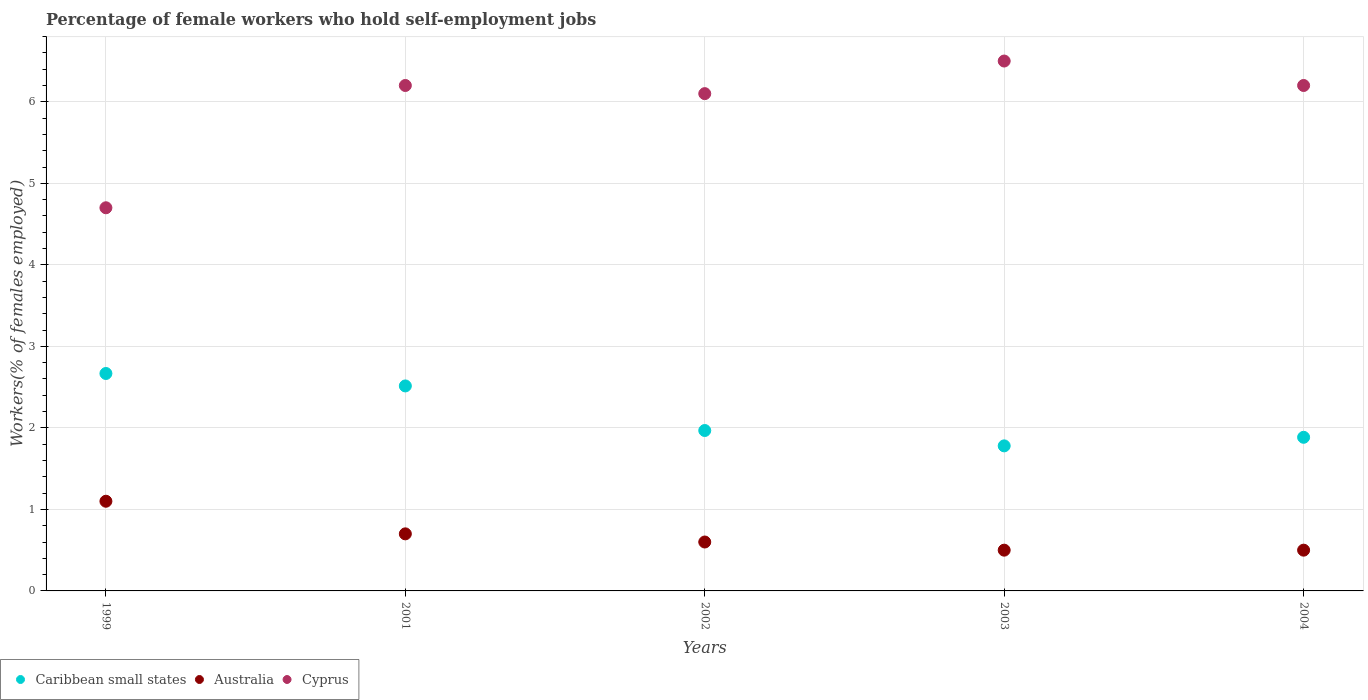Is the number of dotlines equal to the number of legend labels?
Offer a very short reply. Yes. What is the percentage of self-employed female workers in Cyprus in 1999?
Keep it short and to the point. 4.7. Across all years, what is the maximum percentage of self-employed female workers in Australia?
Make the answer very short. 1.1. Across all years, what is the minimum percentage of self-employed female workers in Cyprus?
Offer a very short reply. 4.7. In which year was the percentage of self-employed female workers in Australia maximum?
Offer a terse response. 1999. In which year was the percentage of self-employed female workers in Cyprus minimum?
Keep it short and to the point. 1999. What is the total percentage of self-employed female workers in Australia in the graph?
Provide a short and direct response. 3.4. What is the difference between the percentage of self-employed female workers in Cyprus in 1999 and that in 2002?
Ensure brevity in your answer.  -1.4. What is the difference between the percentage of self-employed female workers in Cyprus in 2004 and the percentage of self-employed female workers in Caribbean small states in 1999?
Ensure brevity in your answer.  3.53. What is the average percentage of self-employed female workers in Australia per year?
Your answer should be compact. 0.68. In the year 2001, what is the difference between the percentage of self-employed female workers in Cyprus and percentage of self-employed female workers in Australia?
Offer a terse response. 5.5. In how many years, is the percentage of self-employed female workers in Cyprus greater than 5.8 %?
Provide a succinct answer. 4. What is the ratio of the percentage of self-employed female workers in Australia in 1999 to that in 2004?
Offer a terse response. 2.2. Is the percentage of self-employed female workers in Caribbean small states in 2001 less than that in 2002?
Your response must be concise. No. What is the difference between the highest and the second highest percentage of self-employed female workers in Caribbean small states?
Provide a succinct answer. 0.15. What is the difference between the highest and the lowest percentage of self-employed female workers in Australia?
Offer a terse response. 0.6. Is the sum of the percentage of self-employed female workers in Caribbean small states in 2001 and 2004 greater than the maximum percentage of self-employed female workers in Cyprus across all years?
Keep it short and to the point. No. Is it the case that in every year, the sum of the percentage of self-employed female workers in Australia and percentage of self-employed female workers in Caribbean small states  is greater than the percentage of self-employed female workers in Cyprus?
Your response must be concise. No. Does the percentage of self-employed female workers in Cyprus monotonically increase over the years?
Provide a short and direct response. No. Is the percentage of self-employed female workers in Cyprus strictly less than the percentage of self-employed female workers in Caribbean small states over the years?
Provide a succinct answer. No. How many dotlines are there?
Give a very brief answer. 3. How many years are there in the graph?
Keep it short and to the point. 5. Are the values on the major ticks of Y-axis written in scientific E-notation?
Offer a very short reply. No. Does the graph contain grids?
Keep it short and to the point. Yes. How many legend labels are there?
Make the answer very short. 3. What is the title of the graph?
Your answer should be compact. Percentage of female workers who hold self-employment jobs. What is the label or title of the Y-axis?
Offer a terse response. Workers(% of females employed). What is the Workers(% of females employed) in Caribbean small states in 1999?
Your answer should be compact. 2.67. What is the Workers(% of females employed) in Australia in 1999?
Offer a terse response. 1.1. What is the Workers(% of females employed) in Cyprus in 1999?
Offer a terse response. 4.7. What is the Workers(% of females employed) of Caribbean small states in 2001?
Your answer should be very brief. 2.51. What is the Workers(% of females employed) of Australia in 2001?
Provide a succinct answer. 0.7. What is the Workers(% of females employed) in Cyprus in 2001?
Keep it short and to the point. 6.2. What is the Workers(% of females employed) in Caribbean small states in 2002?
Provide a succinct answer. 1.97. What is the Workers(% of females employed) of Australia in 2002?
Keep it short and to the point. 0.6. What is the Workers(% of females employed) in Cyprus in 2002?
Provide a short and direct response. 6.1. What is the Workers(% of females employed) of Caribbean small states in 2003?
Provide a succinct answer. 1.78. What is the Workers(% of females employed) of Australia in 2003?
Provide a succinct answer. 0.5. What is the Workers(% of females employed) of Cyprus in 2003?
Offer a terse response. 6.5. What is the Workers(% of females employed) of Caribbean small states in 2004?
Give a very brief answer. 1.88. What is the Workers(% of females employed) of Cyprus in 2004?
Offer a very short reply. 6.2. Across all years, what is the maximum Workers(% of females employed) of Caribbean small states?
Your answer should be very brief. 2.67. Across all years, what is the maximum Workers(% of females employed) in Australia?
Provide a succinct answer. 1.1. Across all years, what is the minimum Workers(% of females employed) of Caribbean small states?
Ensure brevity in your answer.  1.78. Across all years, what is the minimum Workers(% of females employed) in Cyprus?
Your answer should be very brief. 4.7. What is the total Workers(% of females employed) of Caribbean small states in the graph?
Offer a terse response. 10.81. What is the total Workers(% of females employed) in Cyprus in the graph?
Give a very brief answer. 29.7. What is the difference between the Workers(% of females employed) of Caribbean small states in 1999 and that in 2001?
Offer a terse response. 0.15. What is the difference between the Workers(% of females employed) in Cyprus in 1999 and that in 2001?
Offer a very short reply. -1.5. What is the difference between the Workers(% of females employed) in Caribbean small states in 1999 and that in 2002?
Your answer should be very brief. 0.7. What is the difference between the Workers(% of females employed) in Australia in 1999 and that in 2002?
Make the answer very short. 0.5. What is the difference between the Workers(% of females employed) of Caribbean small states in 1999 and that in 2003?
Your answer should be very brief. 0.89. What is the difference between the Workers(% of females employed) of Australia in 1999 and that in 2003?
Your answer should be very brief. 0.6. What is the difference between the Workers(% of females employed) in Caribbean small states in 1999 and that in 2004?
Ensure brevity in your answer.  0.78. What is the difference between the Workers(% of females employed) in Cyprus in 1999 and that in 2004?
Ensure brevity in your answer.  -1.5. What is the difference between the Workers(% of females employed) of Caribbean small states in 2001 and that in 2002?
Ensure brevity in your answer.  0.55. What is the difference between the Workers(% of females employed) in Cyprus in 2001 and that in 2002?
Keep it short and to the point. 0.1. What is the difference between the Workers(% of females employed) of Caribbean small states in 2001 and that in 2003?
Make the answer very short. 0.74. What is the difference between the Workers(% of females employed) in Caribbean small states in 2001 and that in 2004?
Make the answer very short. 0.63. What is the difference between the Workers(% of females employed) of Caribbean small states in 2002 and that in 2003?
Offer a very short reply. 0.19. What is the difference between the Workers(% of females employed) of Australia in 2002 and that in 2003?
Your response must be concise. 0.1. What is the difference between the Workers(% of females employed) of Cyprus in 2002 and that in 2003?
Make the answer very short. -0.4. What is the difference between the Workers(% of females employed) of Caribbean small states in 2002 and that in 2004?
Offer a terse response. 0.08. What is the difference between the Workers(% of females employed) of Caribbean small states in 2003 and that in 2004?
Your response must be concise. -0.11. What is the difference between the Workers(% of females employed) in Cyprus in 2003 and that in 2004?
Your answer should be compact. 0.3. What is the difference between the Workers(% of females employed) in Caribbean small states in 1999 and the Workers(% of females employed) in Australia in 2001?
Ensure brevity in your answer.  1.97. What is the difference between the Workers(% of females employed) in Caribbean small states in 1999 and the Workers(% of females employed) in Cyprus in 2001?
Give a very brief answer. -3.53. What is the difference between the Workers(% of females employed) of Caribbean small states in 1999 and the Workers(% of females employed) of Australia in 2002?
Make the answer very short. 2.07. What is the difference between the Workers(% of females employed) in Caribbean small states in 1999 and the Workers(% of females employed) in Cyprus in 2002?
Give a very brief answer. -3.43. What is the difference between the Workers(% of females employed) in Australia in 1999 and the Workers(% of females employed) in Cyprus in 2002?
Your response must be concise. -5. What is the difference between the Workers(% of females employed) of Caribbean small states in 1999 and the Workers(% of females employed) of Australia in 2003?
Your answer should be compact. 2.17. What is the difference between the Workers(% of females employed) in Caribbean small states in 1999 and the Workers(% of females employed) in Cyprus in 2003?
Keep it short and to the point. -3.83. What is the difference between the Workers(% of females employed) of Caribbean small states in 1999 and the Workers(% of females employed) of Australia in 2004?
Make the answer very short. 2.17. What is the difference between the Workers(% of females employed) in Caribbean small states in 1999 and the Workers(% of females employed) in Cyprus in 2004?
Offer a terse response. -3.53. What is the difference between the Workers(% of females employed) of Australia in 1999 and the Workers(% of females employed) of Cyprus in 2004?
Provide a succinct answer. -5.1. What is the difference between the Workers(% of females employed) in Caribbean small states in 2001 and the Workers(% of females employed) in Australia in 2002?
Keep it short and to the point. 1.91. What is the difference between the Workers(% of females employed) in Caribbean small states in 2001 and the Workers(% of females employed) in Cyprus in 2002?
Offer a terse response. -3.59. What is the difference between the Workers(% of females employed) in Australia in 2001 and the Workers(% of females employed) in Cyprus in 2002?
Offer a terse response. -5.4. What is the difference between the Workers(% of females employed) in Caribbean small states in 2001 and the Workers(% of females employed) in Australia in 2003?
Make the answer very short. 2.01. What is the difference between the Workers(% of females employed) of Caribbean small states in 2001 and the Workers(% of females employed) of Cyprus in 2003?
Your answer should be compact. -3.99. What is the difference between the Workers(% of females employed) in Caribbean small states in 2001 and the Workers(% of females employed) in Australia in 2004?
Your answer should be very brief. 2.01. What is the difference between the Workers(% of females employed) of Caribbean small states in 2001 and the Workers(% of females employed) of Cyprus in 2004?
Your response must be concise. -3.69. What is the difference between the Workers(% of females employed) of Caribbean small states in 2002 and the Workers(% of females employed) of Australia in 2003?
Keep it short and to the point. 1.47. What is the difference between the Workers(% of females employed) of Caribbean small states in 2002 and the Workers(% of females employed) of Cyprus in 2003?
Offer a very short reply. -4.53. What is the difference between the Workers(% of females employed) of Caribbean small states in 2002 and the Workers(% of females employed) of Australia in 2004?
Offer a terse response. 1.47. What is the difference between the Workers(% of females employed) of Caribbean small states in 2002 and the Workers(% of females employed) of Cyprus in 2004?
Offer a very short reply. -4.23. What is the difference between the Workers(% of females employed) of Australia in 2002 and the Workers(% of females employed) of Cyprus in 2004?
Offer a very short reply. -5.6. What is the difference between the Workers(% of females employed) in Caribbean small states in 2003 and the Workers(% of females employed) in Australia in 2004?
Ensure brevity in your answer.  1.28. What is the difference between the Workers(% of females employed) of Caribbean small states in 2003 and the Workers(% of females employed) of Cyprus in 2004?
Make the answer very short. -4.42. What is the average Workers(% of females employed) in Caribbean small states per year?
Ensure brevity in your answer.  2.16. What is the average Workers(% of females employed) of Australia per year?
Your response must be concise. 0.68. What is the average Workers(% of females employed) in Cyprus per year?
Give a very brief answer. 5.94. In the year 1999, what is the difference between the Workers(% of females employed) of Caribbean small states and Workers(% of females employed) of Australia?
Give a very brief answer. 1.57. In the year 1999, what is the difference between the Workers(% of females employed) of Caribbean small states and Workers(% of females employed) of Cyprus?
Provide a short and direct response. -2.03. In the year 2001, what is the difference between the Workers(% of females employed) of Caribbean small states and Workers(% of females employed) of Australia?
Give a very brief answer. 1.81. In the year 2001, what is the difference between the Workers(% of females employed) of Caribbean small states and Workers(% of females employed) of Cyprus?
Provide a succinct answer. -3.69. In the year 2002, what is the difference between the Workers(% of females employed) of Caribbean small states and Workers(% of females employed) of Australia?
Keep it short and to the point. 1.37. In the year 2002, what is the difference between the Workers(% of females employed) of Caribbean small states and Workers(% of females employed) of Cyprus?
Provide a short and direct response. -4.13. In the year 2002, what is the difference between the Workers(% of females employed) of Australia and Workers(% of females employed) of Cyprus?
Keep it short and to the point. -5.5. In the year 2003, what is the difference between the Workers(% of females employed) of Caribbean small states and Workers(% of females employed) of Australia?
Provide a succinct answer. 1.28. In the year 2003, what is the difference between the Workers(% of females employed) of Caribbean small states and Workers(% of females employed) of Cyprus?
Your answer should be very brief. -4.72. In the year 2003, what is the difference between the Workers(% of females employed) of Australia and Workers(% of females employed) of Cyprus?
Provide a short and direct response. -6. In the year 2004, what is the difference between the Workers(% of females employed) of Caribbean small states and Workers(% of females employed) of Australia?
Provide a succinct answer. 1.38. In the year 2004, what is the difference between the Workers(% of females employed) of Caribbean small states and Workers(% of females employed) of Cyprus?
Provide a succinct answer. -4.32. What is the ratio of the Workers(% of females employed) of Caribbean small states in 1999 to that in 2001?
Keep it short and to the point. 1.06. What is the ratio of the Workers(% of females employed) in Australia in 1999 to that in 2001?
Keep it short and to the point. 1.57. What is the ratio of the Workers(% of females employed) of Cyprus in 1999 to that in 2001?
Your response must be concise. 0.76. What is the ratio of the Workers(% of females employed) in Caribbean small states in 1999 to that in 2002?
Give a very brief answer. 1.36. What is the ratio of the Workers(% of females employed) in Australia in 1999 to that in 2002?
Provide a short and direct response. 1.83. What is the ratio of the Workers(% of females employed) of Cyprus in 1999 to that in 2002?
Make the answer very short. 0.77. What is the ratio of the Workers(% of females employed) of Caribbean small states in 1999 to that in 2003?
Offer a terse response. 1.5. What is the ratio of the Workers(% of females employed) of Cyprus in 1999 to that in 2003?
Give a very brief answer. 0.72. What is the ratio of the Workers(% of females employed) in Caribbean small states in 1999 to that in 2004?
Give a very brief answer. 1.42. What is the ratio of the Workers(% of females employed) in Cyprus in 1999 to that in 2004?
Ensure brevity in your answer.  0.76. What is the ratio of the Workers(% of females employed) in Caribbean small states in 2001 to that in 2002?
Provide a short and direct response. 1.28. What is the ratio of the Workers(% of females employed) of Cyprus in 2001 to that in 2002?
Ensure brevity in your answer.  1.02. What is the ratio of the Workers(% of females employed) of Caribbean small states in 2001 to that in 2003?
Offer a terse response. 1.41. What is the ratio of the Workers(% of females employed) in Australia in 2001 to that in 2003?
Give a very brief answer. 1.4. What is the ratio of the Workers(% of females employed) of Cyprus in 2001 to that in 2003?
Provide a short and direct response. 0.95. What is the ratio of the Workers(% of females employed) of Caribbean small states in 2001 to that in 2004?
Make the answer very short. 1.33. What is the ratio of the Workers(% of females employed) in Australia in 2001 to that in 2004?
Ensure brevity in your answer.  1.4. What is the ratio of the Workers(% of females employed) in Caribbean small states in 2002 to that in 2003?
Keep it short and to the point. 1.11. What is the ratio of the Workers(% of females employed) of Australia in 2002 to that in 2003?
Your answer should be very brief. 1.2. What is the ratio of the Workers(% of females employed) in Cyprus in 2002 to that in 2003?
Your response must be concise. 0.94. What is the ratio of the Workers(% of females employed) of Caribbean small states in 2002 to that in 2004?
Make the answer very short. 1.04. What is the ratio of the Workers(% of females employed) of Australia in 2002 to that in 2004?
Ensure brevity in your answer.  1.2. What is the ratio of the Workers(% of females employed) of Cyprus in 2002 to that in 2004?
Your answer should be compact. 0.98. What is the ratio of the Workers(% of females employed) of Caribbean small states in 2003 to that in 2004?
Offer a terse response. 0.94. What is the ratio of the Workers(% of females employed) of Australia in 2003 to that in 2004?
Give a very brief answer. 1. What is the ratio of the Workers(% of females employed) in Cyprus in 2003 to that in 2004?
Give a very brief answer. 1.05. What is the difference between the highest and the second highest Workers(% of females employed) in Caribbean small states?
Ensure brevity in your answer.  0.15. What is the difference between the highest and the second highest Workers(% of females employed) of Cyprus?
Ensure brevity in your answer.  0.3. What is the difference between the highest and the lowest Workers(% of females employed) in Caribbean small states?
Your response must be concise. 0.89. What is the difference between the highest and the lowest Workers(% of females employed) in Australia?
Ensure brevity in your answer.  0.6. 